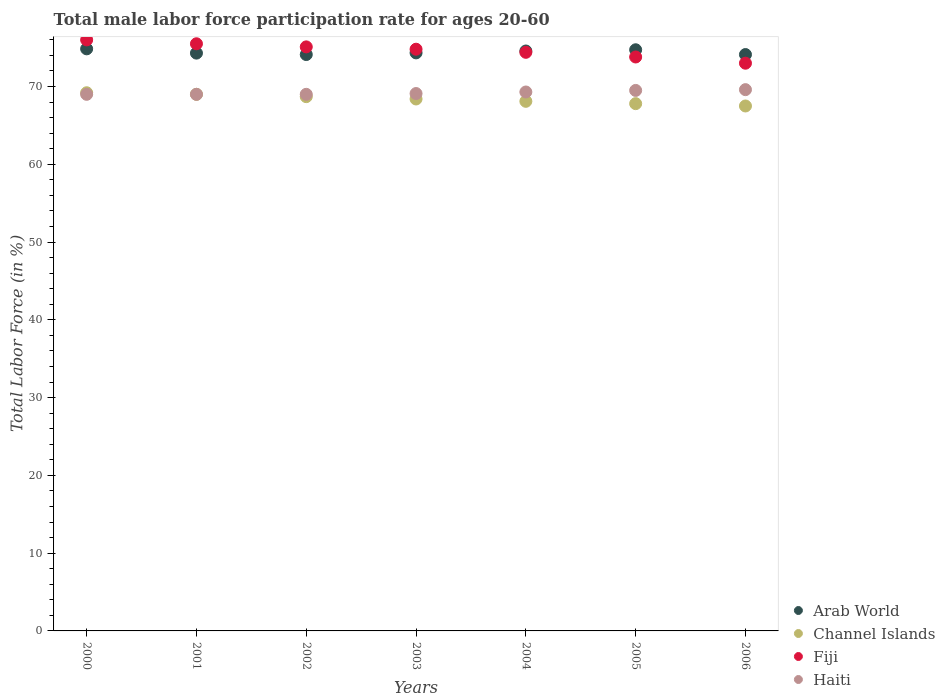What is the male labor force participation rate in Arab World in 2001?
Provide a short and direct response. 74.3. Across all years, what is the maximum male labor force participation rate in Arab World?
Provide a short and direct response. 74.85. Across all years, what is the minimum male labor force participation rate in Channel Islands?
Keep it short and to the point. 67.5. What is the total male labor force participation rate in Channel Islands in the graph?
Your answer should be very brief. 478.7. What is the difference between the male labor force participation rate in Haiti in 2001 and that in 2004?
Keep it short and to the point. -0.3. What is the difference between the male labor force participation rate in Haiti in 2000 and the male labor force participation rate in Fiji in 2005?
Give a very brief answer. -4.8. What is the average male labor force participation rate in Haiti per year?
Provide a succinct answer. 69.21. In the year 2004, what is the difference between the male labor force participation rate in Arab World and male labor force participation rate in Channel Islands?
Provide a succinct answer. 6.47. In how many years, is the male labor force participation rate in Haiti greater than 52 %?
Ensure brevity in your answer.  7. What is the ratio of the male labor force participation rate in Haiti in 2002 to that in 2005?
Your response must be concise. 0.99. Is the male labor force participation rate in Channel Islands in 2005 less than that in 2006?
Make the answer very short. No. What is the difference between the highest and the second highest male labor force participation rate in Channel Islands?
Your answer should be compact. 0.2. What is the difference between the highest and the lowest male labor force participation rate in Arab World?
Make the answer very short. 0.73. Is it the case that in every year, the sum of the male labor force participation rate in Arab World and male labor force participation rate in Haiti  is greater than the sum of male labor force participation rate in Channel Islands and male labor force participation rate in Fiji?
Your answer should be compact. Yes. Is it the case that in every year, the sum of the male labor force participation rate in Channel Islands and male labor force participation rate in Haiti  is greater than the male labor force participation rate in Arab World?
Make the answer very short. Yes. How many dotlines are there?
Keep it short and to the point. 4. How many years are there in the graph?
Provide a short and direct response. 7. What is the difference between two consecutive major ticks on the Y-axis?
Ensure brevity in your answer.  10. Are the values on the major ticks of Y-axis written in scientific E-notation?
Provide a succinct answer. No. What is the title of the graph?
Give a very brief answer. Total male labor force participation rate for ages 20-60. Does "Senegal" appear as one of the legend labels in the graph?
Ensure brevity in your answer.  No. What is the label or title of the X-axis?
Keep it short and to the point. Years. What is the label or title of the Y-axis?
Your answer should be very brief. Total Labor Force (in %). What is the Total Labor Force (in %) in Arab World in 2000?
Your answer should be compact. 74.85. What is the Total Labor Force (in %) of Channel Islands in 2000?
Your answer should be compact. 69.2. What is the Total Labor Force (in %) of Arab World in 2001?
Your answer should be very brief. 74.3. What is the Total Labor Force (in %) in Channel Islands in 2001?
Offer a very short reply. 69. What is the Total Labor Force (in %) in Fiji in 2001?
Offer a very short reply. 75.5. What is the Total Labor Force (in %) in Arab World in 2002?
Provide a succinct answer. 74.11. What is the Total Labor Force (in %) of Channel Islands in 2002?
Offer a terse response. 68.7. What is the Total Labor Force (in %) of Fiji in 2002?
Offer a very short reply. 75.1. What is the Total Labor Force (in %) of Haiti in 2002?
Your answer should be compact. 69. What is the Total Labor Force (in %) of Arab World in 2003?
Give a very brief answer. 74.33. What is the Total Labor Force (in %) of Channel Islands in 2003?
Your answer should be very brief. 68.4. What is the Total Labor Force (in %) in Fiji in 2003?
Offer a very short reply. 74.8. What is the Total Labor Force (in %) in Haiti in 2003?
Make the answer very short. 69.1. What is the Total Labor Force (in %) in Arab World in 2004?
Provide a succinct answer. 74.57. What is the Total Labor Force (in %) in Channel Islands in 2004?
Make the answer very short. 68.1. What is the Total Labor Force (in %) of Fiji in 2004?
Provide a short and direct response. 74.4. What is the Total Labor Force (in %) of Haiti in 2004?
Provide a short and direct response. 69.3. What is the Total Labor Force (in %) in Arab World in 2005?
Give a very brief answer. 74.73. What is the Total Labor Force (in %) in Channel Islands in 2005?
Give a very brief answer. 67.8. What is the Total Labor Force (in %) in Fiji in 2005?
Keep it short and to the point. 73.8. What is the Total Labor Force (in %) in Haiti in 2005?
Provide a short and direct response. 69.5. What is the Total Labor Force (in %) in Arab World in 2006?
Ensure brevity in your answer.  74.11. What is the Total Labor Force (in %) in Channel Islands in 2006?
Your response must be concise. 67.5. What is the Total Labor Force (in %) in Haiti in 2006?
Your response must be concise. 69.6. Across all years, what is the maximum Total Labor Force (in %) in Arab World?
Keep it short and to the point. 74.85. Across all years, what is the maximum Total Labor Force (in %) in Channel Islands?
Your answer should be compact. 69.2. Across all years, what is the maximum Total Labor Force (in %) of Haiti?
Provide a short and direct response. 69.6. Across all years, what is the minimum Total Labor Force (in %) of Arab World?
Give a very brief answer. 74.11. Across all years, what is the minimum Total Labor Force (in %) in Channel Islands?
Your answer should be compact. 67.5. What is the total Total Labor Force (in %) of Arab World in the graph?
Your answer should be very brief. 521. What is the total Total Labor Force (in %) of Channel Islands in the graph?
Offer a terse response. 478.7. What is the total Total Labor Force (in %) of Fiji in the graph?
Offer a very short reply. 522.6. What is the total Total Labor Force (in %) of Haiti in the graph?
Ensure brevity in your answer.  484.5. What is the difference between the Total Labor Force (in %) of Arab World in 2000 and that in 2001?
Provide a succinct answer. 0.55. What is the difference between the Total Labor Force (in %) in Channel Islands in 2000 and that in 2001?
Ensure brevity in your answer.  0.2. What is the difference between the Total Labor Force (in %) in Arab World in 2000 and that in 2002?
Your answer should be very brief. 0.73. What is the difference between the Total Labor Force (in %) in Channel Islands in 2000 and that in 2002?
Ensure brevity in your answer.  0.5. What is the difference between the Total Labor Force (in %) in Haiti in 2000 and that in 2002?
Offer a very short reply. 0. What is the difference between the Total Labor Force (in %) in Arab World in 2000 and that in 2003?
Your response must be concise. 0.52. What is the difference between the Total Labor Force (in %) in Channel Islands in 2000 and that in 2003?
Your answer should be very brief. 0.8. What is the difference between the Total Labor Force (in %) of Fiji in 2000 and that in 2003?
Offer a terse response. 1.2. What is the difference between the Total Labor Force (in %) of Haiti in 2000 and that in 2003?
Make the answer very short. -0.1. What is the difference between the Total Labor Force (in %) of Arab World in 2000 and that in 2004?
Keep it short and to the point. 0.28. What is the difference between the Total Labor Force (in %) in Channel Islands in 2000 and that in 2004?
Your response must be concise. 1.1. What is the difference between the Total Labor Force (in %) in Haiti in 2000 and that in 2004?
Your answer should be very brief. -0.3. What is the difference between the Total Labor Force (in %) in Arab World in 2000 and that in 2005?
Your answer should be compact. 0.12. What is the difference between the Total Labor Force (in %) in Channel Islands in 2000 and that in 2005?
Offer a very short reply. 1.4. What is the difference between the Total Labor Force (in %) of Fiji in 2000 and that in 2005?
Your answer should be very brief. 2.2. What is the difference between the Total Labor Force (in %) in Arab World in 2000 and that in 2006?
Your response must be concise. 0.73. What is the difference between the Total Labor Force (in %) in Fiji in 2000 and that in 2006?
Give a very brief answer. 3. What is the difference between the Total Labor Force (in %) in Haiti in 2000 and that in 2006?
Offer a very short reply. -0.6. What is the difference between the Total Labor Force (in %) of Arab World in 2001 and that in 2002?
Provide a short and direct response. 0.18. What is the difference between the Total Labor Force (in %) of Channel Islands in 2001 and that in 2002?
Provide a short and direct response. 0.3. What is the difference between the Total Labor Force (in %) in Fiji in 2001 and that in 2002?
Your answer should be compact. 0.4. What is the difference between the Total Labor Force (in %) in Haiti in 2001 and that in 2002?
Provide a succinct answer. 0. What is the difference between the Total Labor Force (in %) of Arab World in 2001 and that in 2003?
Give a very brief answer. -0.03. What is the difference between the Total Labor Force (in %) of Channel Islands in 2001 and that in 2003?
Your answer should be compact. 0.6. What is the difference between the Total Labor Force (in %) of Fiji in 2001 and that in 2003?
Provide a short and direct response. 0.7. What is the difference between the Total Labor Force (in %) of Haiti in 2001 and that in 2003?
Your answer should be compact. -0.1. What is the difference between the Total Labor Force (in %) of Arab World in 2001 and that in 2004?
Offer a very short reply. -0.27. What is the difference between the Total Labor Force (in %) of Fiji in 2001 and that in 2004?
Provide a short and direct response. 1.1. What is the difference between the Total Labor Force (in %) in Arab World in 2001 and that in 2005?
Offer a very short reply. -0.43. What is the difference between the Total Labor Force (in %) in Haiti in 2001 and that in 2005?
Offer a very short reply. -0.5. What is the difference between the Total Labor Force (in %) in Arab World in 2001 and that in 2006?
Ensure brevity in your answer.  0.18. What is the difference between the Total Labor Force (in %) of Channel Islands in 2001 and that in 2006?
Give a very brief answer. 1.5. What is the difference between the Total Labor Force (in %) in Fiji in 2001 and that in 2006?
Your answer should be very brief. 2.5. What is the difference between the Total Labor Force (in %) in Haiti in 2001 and that in 2006?
Keep it short and to the point. -0.6. What is the difference between the Total Labor Force (in %) in Arab World in 2002 and that in 2003?
Your response must be concise. -0.21. What is the difference between the Total Labor Force (in %) in Channel Islands in 2002 and that in 2003?
Make the answer very short. 0.3. What is the difference between the Total Labor Force (in %) of Fiji in 2002 and that in 2003?
Your answer should be compact. 0.3. What is the difference between the Total Labor Force (in %) of Arab World in 2002 and that in 2004?
Your response must be concise. -0.46. What is the difference between the Total Labor Force (in %) of Fiji in 2002 and that in 2004?
Give a very brief answer. 0.7. What is the difference between the Total Labor Force (in %) of Arab World in 2002 and that in 2005?
Make the answer very short. -0.62. What is the difference between the Total Labor Force (in %) in Channel Islands in 2002 and that in 2005?
Make the answer very short. 0.9. What is the difference between the Total Labor Force (in %) of Haiti in 2002 and that in 2005?
Provide a short and direct response. -0.5. What is the difference between the Total Labor Force (in %) in Arab World in 2002 and that in 2006?
Make the answer very short. -0. What is the difference between the Total Labor Force (in %) of Fiji in 2002 and that in 2006?
Ensure brevity in your answer.  2.1. What is the difference between the Total Labor Force (in %) in Haiti in 2002 and that in 2006?
Your answer should be very brief. -0.6. What is the difference between the Total Labor Force (in %) in Arab World in 2003 and that in 2004?
Ensure brevity in your answer.  -0.24. What is the difference between the Total Labor Force (in %) in Channel Islands in 2003 and that in 2004?
Your answer should be very brief. 0.3. What is the difference between the Total Labor Force (in %) in Arab World in 2003 and that in 2005?
Ensure brevity in your answer.  -0.4. What is the difference between the Total Labor Force (in %) of Fiji in 2003 and that in 2005?
Your response must be concise. 1. What is the difference between the Total Labor Force (in %) of Arab World in 2003 and that in 2006?
Offer a terse response. 0.21. What is the difference between the Total Labor Force (in %) in Haiti in 2003 and that in 2006?
Your response must be concise. -0.5. What is the difference between the Total Labor Force (in %) in Arab World in 2004 and that in 2005?
Give a very brief answer. -0.16. What is the difference between the Total Labor Force (in %) of Fiji in 2004 and that in 2005?
Your answer should be compact. 0.6. What is the difference between the Total Labor Force (in %) of Arab World in 2004 and that in 2006?
Your answer should be very brief. 0.46. What is the difference between the Total Labor Force (in %) in Haiti in 2004 and that in 2006?
Give a very brief answer. -0.3. What is the difference between the Total Labor Force (in %) in Arab World in 2005 and that in 2006?
Make the answer very short. 0.61. What is the difference between the Total Labor Force (in %) of Channel Islands in 2005 and that in 2006?
Ensure brevity in your answer.  0.3. What is the difference between the Total Labor Force (in %) of Arab World in 2000 and the Total Labor Force (in %) of Channel Islands in 2001?
Offer a very short reply. 5.85. What is the difference between the Total Labor Force (in %) in Arab World in 2000 and the Total Labor Force (in %) in Fiji in 2001?
Your answer should be very brief. -0.65. What is the difference between the Total Labor Force (in %) in Arab World in 2000 and the Total Labor Force (in %) in Haiti in 2001?
Your response must be concise. 5.85. What is the difference between the Total Labor Force (in %) in Channel Islands in 2000 and the Total Labor Force (in %) in Haiti in 2001?
Provide a short and direct response. 0.2. What is the difference between the Total Labor Force (in %) of Fiji in 2000 and the Total Labor Force (in %) of Haiti in 2001?
Keep it short and to the point. 7. What is the difference between the Total Labor Force (in %) in Arab World in 2000 and the Total Labor Force (in %) in Channel Islands in 2002?
Offer a terse response. 6.15. What is the difference between the Total Labor Force (in %) in Arab World in 2000 and the Total Labor Force (in %) in Fiji in 2002?
Ensure brevity in your answer.  -0.25. What is the difference between the Total Labor Force (in %) in Arab World in 2000 and the Total Labor Force (in %) in Haiti in 2002?
Offer a terse response. 5.85. What is the difference between the Total Labor Force (in %) in Arab World in 2000 and the Total Labor Force (in %) in Channel Islands in 2003?
Provide a short and direct response. 6.45. What is the difference between the Total Labor Force (in %) of Arab World in 2000 and the Total Labor Force (in %) of Fiji in 2003?
Provide a succinct answer. 0.05. What is the difference between the Total Labor Force (in %) in Arab World in 2000 and the Total Labor Force (in %) in Haiti in 2003?
Make the answer very short. 5.75. What is the difference between the Total Labor Force (in %) of Channel Islands in 2000 and the Total Labor Force (in %) of Fiji in 2003?
Give a very brief answer. -5.6. What is the difference between the Total Labor Force (in %) of Channel Islands in 2000 and the Total Labor Force (in %) of Haiti in 2003?
Offer a terse response. 0.1. What is the difference between the Total Labor Force (in %) in Fiji in 2000 and the Total Labor Force (in %) in Haiti in 2003?
Offer a very short reply. 6.9. What is the difference between the Total Labor Force (in %) of Arab World in 2000 and the Total Labor Force (in %) of Channel Islands in 2004?
Ensure brevity in your answer.  6.75. What is the difference between the Total Labor Force (in %) of Arab World in 2000 and the Total Labor Force (in %) of Fiji in 2004?
Keep it short and to the point. 0.45. What is the difference between the Total Labor Force (in %) in Arab World in 2000 and the Total Labor Force (in %) in Haiti in 2004?
Give a very brief answer. 5.55. What is the difference between the Total Labor Force (in %) in Channel Islands in 2000 and the Total Labor Force (in %) in Fiji in 2004?
Keep it short and to the point. -5.2. What is the difference between the Total Labor Force (in %) in Fiji in 2000 and the Total Labor Force (in %) in Haiti in 2004?
Provide a succinct answer. 6.7. What is the difference between the Total Labor Force (in %) in Arab World in 2000 and the Total Labor Force (in %) in Channel Islands in 2005?
Ensure brevity in your answer.  7.05. What is the difference between the Total Labor Force (in %) in Arab World in 2000 and the Total Labor Force (in %) in Fiji in 2005?
Your response must be concise. 1.05. What is the difference between the Total Labor Force (in %) of Arab World in 2000 and the Total Labor Force (in %) of Haiti in 2005?
Ensure brevity in your answer.  5.35. What is the difference between the Total Labor Force (in %) in Channel Islands in 2000 and the Total Labor Force (in %) in Fiji in 2005?
Your response must be concise. -4.6. What is the difference between the Total Labor Force (in %) in Channel Islands in 2000 and the Total Labor Force (in %) in Haiti in 2005?
Provide a succinct answer. -0.3. What is the difference between the Total Labor Force (in %) of Fiji in 2000 and the Total Labor Force (in %) of Haiti in 2005?
Your response must be concise. 6.5. What is the difference between the Total Labor Force (in %) in Arab World in 2000 and the Total Labor Force (in %) in Channel Islands in 2006?
Offer a very short reply. 7.35. What is the difference between the Total Labor Force (in %) in Arab World in 2000 and the Total Labor Force (in %) in Fiji in 2006?
Provide a succinct answer. 1.85. What is the difference between the Total Labor Force (in %) in Arab World in 2000 and the Total Labor Force (in %) in Haiti in 2006?
Your answer should be very brief. 5.25. What is the difference between the Total Labor Force (in %) of Channel Islands in 2000 and the Total Labor Force (in %) of Fiji in 2006?
Your answer should be very brief. -3.8. What is the difference between the Total Labor Force (in %) of Channel Islands in 2000 and the Total Labor Force (in %) of Haiti in 2006?
Ensure brevity in your answer.  -0.4. What is the difference between the Total Labor Force (in %) in Fiji in 2000 and the Total Labor Force (in %) in Haiti in 2006?
Your answer should be very brief. 6.4. What is the difference between the Total Labor Force (in %) in Arab World in 2001 and the Total Labor Force (in %) in Channel Islands in 2002?
Your response must be concise. 5.6. What is the difference between the Total Labor Force (in %) in Arab World in 2001 and the Total Labor Force (in %) in Fiji in 2002?
Give a very brief answer. -0.8. What is the difference between the Total Labor Force (in %) of Arab World in 2001 and the Total Labor Force (in %) of Haiti in 2002?
Provide a short and direct response. 5.3. What is the difference between the Total Labor Force (in %) of Channel Islands in 2001 and the Total Labor Force (in %) of Fiji in 2002?
Give a very brief answer. -6.1. What is the difference between the Total Labor Force (in %) in Channel Islands in 2001 and the Total Labor Force (in %) in Haiti in 2002?
Offer a very short reply. 0. What is the difference between the Total Labor Force (in %) in Arab World in 2001 and the Total Labor Force (in %) in Channel Islands in 2003?
Keep it short and to the point. 5.9. What is the difference between the Total Labor Force (in %) in Arab World in 2001 and the Total Labor Force (in %) in Fiji in 2003?
Make the answer very short. -0.5. What is the difference between the Total Labor Force (in %) of Arab World in 2001 and the Total Labor Force (in %) of Haiti in 2003?
Offer a terse response. 5.2. What is the difference between the Total Labor Force (in %) of Channel Islands in 2001 and the Total Labor Force (in %) of Haiti in 2003?
Make the answer very short. -0.1. What is the difference between the Total Labor Force (in %) of Fiji in 2001 and the Total Labor Force (in %) of Haiti in 2003?
Provide a short and direct response. 6.4. What is the difference between the Total Labor Force (in %) of Arab World in 2001 and the Total Labor Force (in %) of Channel Islands in 2004?
Make the answer very short. 6.2. What is the difference between the Total Labor Force (in %) in Arab World in 2001 and the Total Labor Force (in %) in Fiji in 2004?
Make the answer very short. -0.1. What is the difference between the Total Labor Force (in %) in Arab World in 2001 and the Total Labor Force (in %) in Haiti in 2004?
Ensure brevity in your answer.  5. What is the difference between the Total Labor Force (in %) in Channel Islands in 2001 and the Total Labor Force (in %) in Fiji in 2004?
Keep it short and to the point. -5.4. What is the difference between the Total Labor Force (in %) in Arab World in 2001 and the Total Labor Force (in %) in Channel Islands in 2005?
Provide a short and direct response. 6.5. What is the difference between the Total Labor Force (in %) of Arab World in 2001 and the Total Labor Force (in %) of Fiji in 2005?
Offer a terse response. 0.5. What is the difference between the Total Labor Force (in %) in Arab World in 2001 and the Total Labor Force (in %) in Haiti in 2005?
Ensure brevity in your answer.  4.8. What is the difference between the Total Labor Force (in %) in Channel Islands in 2001 and the Total Labor Force (in %) in Haiti in 2005?
Keep it short and to the point. -0.5. What is the difference between the Total Labor Force (in %) in Arab World in 2001 and the Total Labor Force (in %) in Channel Islands in 2006?
Your answer should be very brief. 6.8. What is the difference between the Total Labor Force (in %) of Arab World in 2001 and the Total Labor Force (in %) of Fiji in 2006?
Offer a very short reply. 1.3. What is the difference between the Total Labor Force (in %) in Arab World in 2001 and the Total Labor Force (in %) in Haiti in 2006?
Provide a succinct answer. 4.7. What is the difference between the Total Labor Force (in %) of Channel Islands in 2001 and the Total Labor Force (in %) of Fiji in 2006?
Ensure brevity in your answer.  -4. What is the difference between the Total Labor Force (in %) of Channel Islands in 2001 and the Total Labor Force (in %) of Haiti in 2006?
Give a very brief answer. -0.6. What is the difference between the Total Labor Force (in %) in Fiji in 2001 and the Total Labor Force (in %) in Haiti in 2006?
Give a very brief answer. 5.9. What is the difference between the Total Labor Force (in %) of Arab World in 2002 and the Total Labor Force (in %) of Channel Islands in 2003?
Ensure brevity in your answer.  5.71. What is the difference between the Total Labor Force (in %) of Arab World in 2002 and the Total Labor Force (in %) of Fiji in 2003?
Your response must be concise. -0.69. What is the difference between the Total Labor Force (in %) of Arab World in 2002 and the Total Labor Force (in %) of Haiti in 2003?
Your response must be concise. 5.01. What is the difference between the Total Labor Force (in %) of Channel Islands in 2002 and the Total Labor Force (in %) of Fiji in 2003?
Make the answer very short. -6.1. What is the difference between the Total Labor Force (in %) in Fiji in 2002 and the Total Labor Force (in %) in Haiti in 2003?
Your answer should be very brief. 6. What is the difference between the Total Labor Force (in %) in Arab World in 2002 and the Total Labor Force (in %) in Channel Islands in 2004?
Keep it short and to the point. 6.01. What is the difference between the Total Labor Force (in %) of Arab World in 2002 and the Total Labor Force (in %) of Fiji in 2004?
Offer a very short reply. -0.29. What is the difference between the Total Labor Force (in %) of Arab World in 2002 and the Total Labor Force (in %) of Haiti in 2004?
Your response must be concise. 4.81. What is the difference between the Total Labor Force (in %) in Fiji in 2002 and the Total Labor Force (in %) in Haiti in 2004?
Your response must be concise. 5.8. What is the difference between the Total Labor Force (in %) in Arab World in 2002 and the Total Labor Force (in %) in Channel Islands in 2005?
Offer a very short reply. 6.31. What is the difference between the Total Labor Force (in %) of Arab World in 2002 and the Total Labor Force (in %) of Fiji in 2005?
Make the answer very short. 0.31. What is the difference between the Total Labor Force (in %) of Arab World in 2002 and the Total Labor Force (in %) of Haiti in 2005?
Give a very brief answer. 4.61. What is the difference between the Total Labor Force (in %) in Channel Islands in 2002 and the Total Labor Force (in %) in Fiji in 2005?
Provide a short and direct response. -5.1. What is the difference between the Total Labor Force (in %) in Channel Islands in 2002 and the Total Labor Force (in %) in Haiti in 2005?
Keep it short and to the point. -0.8. What is the difference between the Total Labor Force (in %) of Fiji in 2002 and the Total Labor Force (in %) of Haiti in 2005?
Keep it short and to the point. 5.6. What is the difference between the Total Labor Force (in %) of Arab World in 2002 and the Total Labor Force (in %) of Channel Islands in 2006?
Offer a very short reply. 6.61. What is the difference between the Total Labor Force (in %) of Arab World in 2002 and the Total Labor Force (in %) of Fiji in 2006?
Your response must be concise. 1.11. What is the difference between the Total Labor Force (in %) in Arab World in 2002 and the Total Labor Force (in %) in Haiti in 2006?
Keep it short and to the point. 4.51. What is the difference between the Total Labor Force (in %) in Channel Islands in 2002 and the Total Labor Force (in %) in Fiji in 2006?
Provide a succinct answer. -4.3. What is the difference between the Total Labor Force (in %) in Arab World in 2003 and the Total Labor Force (in %) in Channel Islands in 2004?
Your response must be concise. 6.23. What is the difference between the Total Labor Force (in %) in Arab World in 2003 and the Total Labor Force (in %) in Fiji in 2004?
Ensure brevity in your answer.  -0.07. What is the difference between the Total Labor Force (in %) in Arab World in 2003 and the Total Labor Force (in %) in Haiti in 2004?
Your answer should be compact. 5.03. What is the difference between the Total Labor Force (in %) of Channel Islands in 2003 and the Total Labor Force (in %) of Haiti in 2004?
Provide a succinct answer. -0.9. What is the difference between the Total Labor Force (in %) in Arab World in 2003 and the Total Labor Force (in %) in Channel Islands in 2005?
Your answer should be very brief. 6.53. What is the difference between the Total Labor Force (in %) in Arab World in 2003 and the Total Labor Force (in %) in Fiji in 2005?
Make the answer very short. 0.53. What is the difference between the Total Labor Force (in %) of Arab World in 2003 and the Total Labor Force (in %) of Haiti in 2005?
Ensure brevity in your answer.  4.83. What is the difference between the Total Labor Force (in %) in Channel Islands in 2003 and the Total Labor Force (in %) in Fiji in 2005?
Give a very brief answer. -5.4. What is the difference between the Total Labor Force (in %) in Channel Islands in 2003 and the Total Labor Force (in %) in Haiti in 2005?
Ensure brevity in your answer.  -1.1. What is the difference between the Total Labor Force (in %) of Fiji in 2003 and the Total Labor Force (in %) of Haiti in 2005?
Offer a very short reply. 5.3. What is the difference between the Total Labor Force (in %) in Arab World in 2003 and the Total Labor Force (in %) in Channel Islands in 2006?
Ensure brevity in your answer.  6.83. What is the difference between the Total Labor Force (in %) of Arab World in 2003 and the Total Labor Force (in %) of Fiji in 2006?
Your answer should be compact. 1.33. What is the difference between the Total Labor Force (in %) of Arab World in 2003 and the Total Labor Force (in %) of Haiti in 2006?
Provide a succinct answer. 4.73. What is the difference between the Total Labor Force (in %) in Channel Islands in 2003 and the Total Labor Force (in %) in Fiji in 2006?
Ensure brevity in your answer.  -4.6. What is the difference between the Total Labor Force (in %) in Channel Islands in 2003 and the Total Labor Force (in %) in Haiti in 2006?
Provide a short and direct response. -1.2. What is the difference between the Total Labor Force (in %) in Arab World in 2004 and the Total Labor Force (in %) in Channel Islands in 2005?
Offer a terse response. 6.77. What is the difference between the Total Labor Force (in %) in Arab World in 2004 and the Total Labor Force (in %) in Fiji in 2005?
Make the answer very short. 0.77. What is the difference between the Total Labor Force (in %) in Arab World in 2004 and the Total Labor Force (in %) in Haiti in 2005?
Make the answer very short. 5.07. What is the difference between the Total Labor Force (in %) in Channel Islands in 2004 and the Total Labor Force (in %) in Fiji in 2005?
Make the answer very short. -5.7. What is the difference between the Total Labor Force (in %) of Channel Islands in 2004 and the Total Labor Force (in %) of Haiti in 2005?
Give a very brief answer. -1.4. What is the difference between the Total Labor Force (in %) of Arab World in 2004 and the Total Labor Force (in %) of Channel Islands in 2006?
Offer a very short reply. 7.07. What is the difference between the Total Labor Force (in %) of Arab World in 2004 and the Total Labor Force (in %) of Fiji in 2006?
Keep it short and to the point. 1.57. What is the difference between the Total Labor Force (in %) in Arab World in 2004 and the Total Labor Force (in %) in Haiti in 2006?
Offer a terse response. 4.97. What is the difference between the Total Labor Force (in %) of Channel Islands in 2004 and the Total Labor Force (in %) of Haiti in 2006?
Your answer should be compact. -1.5. What is the difference between the Total Labor Force (in %) in Arab World in 2005 and the Total Labor Force (in %) in Channel Islands in 2006?
Offer a very short reply. 7.23. What is the difference between the Total Labor Force (in %) in Arab World in 2005 and the Total Labor Force (in %) in Fiji in 2006?
Keep it short and to the point. 1.73. What is the difference between the Total Labor Force (in %) in Arab World in 2005 and the Total Labor Force (in %) in Haiti in 2006?
Offer a terse response. 5.13. What is the difference between the Total Labor Force (in %) of Channel Islands in 2005 and the Total Labor Force (in %) of Fiji in 2006?
Your answer should be compact. -5.2. What is the difference between the Total Labor Force (in %) in Channel Islands in 2005 and the Total Labor Force (in %) in Haiti in 2006?
Your answer should be compact. -1.8. What is the average Total Labor Force (in %) of Arab World per year?
Ensure brevity in your answer.  74.43. What is the average Total Labor Force (in %) of Channel Islands per year?
Keep it short and to the point. 68.39. What is the average Total Labor Force (in %) in Fiji per year?
Provide a short and direct response. 74.66. What is the average Total Labor Force (in %) of Haiti per year?
Provide a succinct answer. 69.21. In the year 2000, what is the difference between the Total Labor Force (in %) in Arab World and Total Labor Force (in %) in Channel Islands?
Provide a short and direct response. 5.65. In the year 2000, what is the difference between the Total Labor Force (in %) of Arab World and Total Labor Force (in %) of Fiji?
Make the answer very short. -1.15. In the year 2000, what is the difference between the Total Labor Force (in %) in Arab World and Total Labor Force (in %) in Haiti?
Offer a terse response. 5.85. In the year 2000, what is the difference between the Total Labor Force (in %) in Channel Islands and Total Labor Force (in %) in Haiti?
Give a very brief answer. 0.2. In the year 2001, what is the difference between the Total Labor Force (in %) in Arab World and Total Labor Force (in %) in Channel Islands?
Keep it short and to the point. 5.3. In the year 2001, what is the difference between the Total Labor Force (in %) in Arab World and Total Labor Force (in %) in Fiji?
Provide a succinct answer. -1.2. In the year 2001, what is the difference between the Total Labor Force (in %) in Arab World and Total Labor Force (in %) in Haiti?
Your response must be concise. 5.3. In the year 2001, what is the difference between the Total Labor Force (in %) in Channel Islands and Total Labor Force (in %) in Haiti?
Provide a succinct answer. 0. In the year 2002, what is the difference between the Total Labor Force (in %) in Arab World and Total Labor Force (in %) in Channel Islands?
Offer a terse response. 5.41. In the year 2002, what is the difference between the Total Labor Force (in %) in Arab World and Total Labor Force (in %) in Fiji?
Your answer should be compact. -0.99. In the year 2002, what is the difference between the Total Labor Force (in %) of Arab World and Total Labor Force (in %) of Haiti?
Keep it short and to the point. 5.11. In the year 2002, what is the difference between the Total Labor Force (in %) in Channel Islands and Total Labor Force (in %) in Haiti?
Your response must be concise. -0.3. In the year 2002, what is the difference between the Total Labor Force (in %) in Fiji and Total Labor Force (in %) in Haiti?
Give a very brief answer. 6.1. In the year 2003, what is the difference between the Total Labor Force (in %) of Arab World and Total Labor Force (in %) of Channel Islands?
Keep it short and to the point. 5.93. In the year 2003, what is the difference between the Total Labor Force (in %) in Arab World and Total Labor Force (in %) in Fiji?
Provide a short and direct response. -0.47. In the year 2003, what is the difference between the Total Labor Force (in %) of Arab World and Total Labor Force (in %) of Haiti?
Offer a very short reply. 5.23. In the year 2003, what is the difference between the Total Labor Force (in %) in Channel Islands and Total Labor Force (in %) in Fiji?
Offer a very short reply. -6.4. In the year 2003, what is the difference between the Total Labor Force (in %) in Channel Islands and Total Labor Force (in %) in Haiti?
Offer a terse response. -0.7. In the year 2003, what is the difference between the Total Labor Force (in %) in Fiji and Total Labor Force (in %) in Haiti?
Your response must be concise. 5.7. In the year 2004, what is the difference between the Total Labor Force (in %) in Arab World and Total Labor Force (in %) in Channel Islands?
Make the answer very short. 6.47. In the year 2004, what is the difference between the Total Labor Force (in %) in Arab World and Total Labor Force (in %) in Fiji?
Keep it short and to the point. 0.17. In the year 2004, what is the difference between the Total Labor Force (in %) in Arab World and Total Labor Force (in %) in Haiti?
Offer a terse response. 5.27. In the year 2004, what is the difference between the Total Labor Force (in %) in Channel Islands and Total Labor Force (in %) in Fiji?
Ensure brevity in your answer.  -6.3. In the year 2004, what is the difference between the Total Labor Force (in %) of Fiji and Total Labor Force (in %) of Haiti?
Provide a succinct answer. 5.1. In the year 2005, what is the difference between the Total Labor Force (in %) in Arab World and Total Labor Force (in %) in Channel Islands?
Provide a succinct answer. 6.93. In the year 2005, what is the difference between the Total Labor Force (in %) of Arab World and Total Labor Force (in %) of Fiji?
Provide a short and direct response. 0.93. In the year 2005, what is the difference between the Total Labor Force (in %) in Arab World and Total Labor Force (in %) in Haiti?
Provide a short and direct response. 5.23. In the year 2005, what is the difference between the Total Labor Force (in %) of Channel Islands and Total Labor Force (in %) of Fiji?
Your answer should be compact. -6. In the year 2005, what is the difference between the Total Labor Force (in %) of Channel Islands and Total Labor Force (in %) of Haiti?
Provide a short and direct response. -1.7. In the year 2005, what is the difference between the Total Labor Force (in %) in Fiji and Total Labor Force (in %) in Haiti?
Ensure brevity in your answer.  4.3. In the year 2006, what is the difference between the Total Labor Force (in %) in Arab World and Total Labor Force (in %) in Channel Islands?
Keep it short and to the point. 6.61. In the year 2006, what is the difference between the Total Labor Force (in %) in Arab World and Total Labor Force (in %) in Fiji?
Your response must be concise. 1.11. In the year 2006, what is the difference between the Total Labor Force (in %) of Arab World and Total Labor Force (in %) of Haiti?
Your response must be concise. 4.51. In the year 2006, what is the difference between the Total Labor Force (in %) of Channel Islands and Total Labor Force (in %) of Haiti?
Offer a very short reply. -2.1. What is the ratio of the Total Labor Force (in %) in Arab World in 2000 to that in 2001?
Your answer should be very brief. 1.01. What is the ratio of the Total Labor Force (in %) in Fiji in 2000 to that in 2001?
Provide a short and direct response. 1.01. What is the ratio of the Total Labor Force (in %) in Arab World in 2000 to that in 2002?
Your response must be concise. 1.01. What is the ratio of the Total Labor Force (in %) in Channel Islands in 2000 to that in 2002?
Offer a terse response. 1.01. What is the ratio of the Total Labor Force (in %) in Haiti in 2000 to that in 2002?
Provide a succinct answer. 1. What is the ratio of the Total Labor Force (in %) of Arab World in 2000 to that in 2003?
Ensure brevity in your answer.  1.01. What is the ratio of the Total Labor Force (in %) in Channel Islands in 2000 to that in 2003?
Offer a very short reply. 1.01. What is the ratio of the Total Labor Force (in %) in Haiti in 2000 to that in 2003?
Ensure brevity in your answer.  1. What is the ratio of the Total Labor Force (in %) of Arab World in 2000 to that in 2004?
Provide a short and direct response. 1. What is the ratio of the Total Labor Force (in %) of Channel Islands in 2000 to that in 2004?
Make the answer very short. 1.02. What is the ratio of the Total Labor Force (in %) in Fiji in 2000 to that in 2004?
Your answer should be compact. 1.02. What is the ratio of the Total Labor Force (in %) in Haiti in 2000 to that in 2004?
Your answer should be very brief. 1. What is the ratio of the Total Labor Force (in %) of Channel Islands in 2000 to that in 2005?
Give a very brief answer. 1.02. What is the ratio of the Total Labor Force (in %) of Fiji in 2000 to that in 2005?
Your answer should be compact. 1.03. What is the ratio of the Total Labor Force (in %) of Haiti in 2000 to that in 2005?
Make the answer very short. 0.99. What is the ratio of the Total Labor Force (in %) of Arab World in 2000 to that in 2006?
Provide a short and direct response. 1.01. What is the ratio of the Total Labor Force (in %) in Channel Islands in 2000 to that in 2006?
Your answer should be very brief. 1.03. What is the ratio of the Total Labor Force (in %) in Fiji in 2000 to that in 2006?
Provide a short and direct response. 1.04. What is the ratio of the Total Labor Force (in %) of Haiti in 2001 to that in 2002?
Your answer should be compact. 1. What is the ratio of the Total Labor Force (in %) in Arab World in 2001 to that in 2003?
Keep it short and to the point. 1. What is the ratio of the Total Labor Force (in %) in Channel Islands in 2001 to that in 2003?
Provide a short and direct response. 1.01. What is the ratio of the Total Labor Force (in %) in Fiji in 2001 to that in 2003?
Provide a succinct answer. 1.01. What is the ratio of the Total Labor Force (in %) in Haiti in 2001 to that in 2003?
Offer a terse response. 1. What is the ratio of the Total Labor Force (in %) in Arab World in 2001 to that in 2004?
Provide a succinct answer. 1. What is the ratio of the Total Labor Force (in %) in Channel Islands in 2001 to that in 2004?
Your answer should be compact. 1.01. What is the ratio of the Total Labor Force (in %) in Fiji in 2001 to that in 2004?
Keep it short and to the point. 1.01. What is the ratio of the Total Labor Force (in %) in Haiti in 2001 to that in 2004?
Your answer should be very brief. 1. What is the ratio of the Total Labor Force (in %) in Arab World in 2001 to that in 2005?
Keep it short and to the point. 0.99. What is the ratio of the Total Labor Force (in %) in Channel Islands in 2001 to that in 2005?
Your answer should be compact. 1.02. What is the ratio of the Total Labor Force (in %) of Fiji in 2001 to that in 2005?
Offer a very short reply. 1.02. What is the ratio of the Total Labor Force (in %) in Channel Islands in 2001 to that in 2006?
Offer a terse response. 1.02. What is the ratio of the Total Labor Force (in %) in Fiji in 2001 to that in 2006?
Keep it short and to the point. 1.03. What is the ratio of the Total Labor Force (in %) in Haiti in 2001 to that in 2006?
Provide a succinct answer. 0.99. What is the ratio of the Total Labor Force (in %) in Arab World in 2002 to that in 2003?
Offer a very short reply. 1. What is the ratio of the Total Labor Force (in %) in Channel Islands in 2002 to that in 2003?
Your response must be concise. 1. What is the ratio of the Total Labor Force (in %) of Fiji in 2002 to that in 2003?
Keep it short and to the point. 1. What is the ratio of the Total Labor Force (in %) of Arab World in 2002 to that in 2004?
Keep it short and to the point. 0.99. What is the ratio of the Total Labor Force (in %) of Channel Islands in 2002 to that in 2004?
Offer a very short reply. 1.01. What is the ratio of the Total Labor Force (in %) of Fiji in 2002 to that in 2004?
Your answer should be compact. 1.01. What is the ratio of the Total Labor Force (in %) of Haiti in 2002 to that in 2004?
Offer a very short reply. 1. What is the ratio of the Total Labor Force (in %) in Arab World in 2002 to that in 2005?
Provide a succinct answer. 0.99. What is the ratio of the Total Labor Force (in %) in Channel Islands in 2002 to that in 2005?
Your response must be concise. 1.01. What is the ratio of the Total Labor Force (in %) of Fiji in 2002 to that in 2005?
Offer a very short reply. 1.02. What is the ratio of the Total Labor Force (in %) in Arab World in 2002 to that in 2006?
Make the answer very short. 1. What is the ratio of the Total Labor Force (in %) of Channel Islands in 2002 to that in 2006?
Provide a succinct answer. 1.02. What is the ratio of the Total Labor Force (in %) in Fiji in 2002 to that in 2006?
Make the answer very short. 1.03. What is the ratio of the Total Labor Force (in %) in Haiti in 2002 to that in 2006?
Your response must be concise. 0.99. What is the ratio of the Total Labor Force (in %) in Channel Islands in 2003 to that in 2004?
Provide a succinct answer. 1. What is the ratio of the Total Labor Force (in %) in Fiji in 2003 to that in 2004?
Give a very brief answer. 1.01. What is the ratio of the Total Labor Force (in %) of Haiti in 2003 to that in 2004?
Offer a very short reply. 1. What is the ratio of the Total Labor Force (in %) in Channel Islands in 2003 to that in 2005?
Keep it short and to the point. 1.01. What is the ratio of the Total Labor Force (in %) of Fiji in 2003 to that in 2005?
Provide a short and direct response. 1.01. What is the ratio of the Total Labor Force (in %) of Haiti in 2003 to that in 2005?
Offer a terse response. 0.99. What is the ratio of the Total Labor Force (in %) of Arab World in 2003 to that in 2006?
Your response must be concise. 1. What is the ratio of the Total Labor Force (in %) of Channel Islands in 2003 to that in 2006?
Your answer should be very brief. 1.01. What is the ratio of the Total Labor Force (in %) in Fiji in 2003 to that in 2006?
Your response must be concise. 1.02. What is the ratio of the Total Labor Force (in %) of Haiti in 2003 to that in 2006?
Provide a succinct answer. 0.99. What is the ratio of the Total Labor Force (in %) of Channel Islands in 2004 to that in 2005?
Your answer should be compact. 1. What is the ratio of the Total Labor Force (in %) in Channel Islands in 2004 to that in 2006?
Offer a very short reply. 1.01. What is the ratio of the Total Labor Force (in %) in Fiji in 2004 to that in 2006?
Provide a short and direct response. 1.02. What is the ratio of the Total Labor Force (in %) of Arab World in 2005 to that in 2006?
Offer a very short reply. 1.01. What is the ratio of the Total Labor Force (in %) in Channel Islands in 2005 to that in 2006?
Keep it short and to the point. 1. What is the difference between the highest and the second highest Total Labor Force (in %) of Arab World?
Make the answer very short. 0.12. What is the difference between the highest and the second highest Total Labor Force (in %) of Fiji?
Your response must be concise. 0.5. What is the difference between the highest and the lowest Total Labor Force (in %) in Arab World?
Your answer should be very brief. 0.73. What is the difference between the highest and the lowest Total Labor Force (in %) of Channel Islands?
Provide a short and direct response. 1.7. What is the difference between the highest and the lowest Total Labor Force (in %) in Fiji?
Your answer should be very brief. 3. What is the difference between the highest and the lowest Total Labor Force (in %) of Haiti?
Provide a short and direct response. 0.6. 